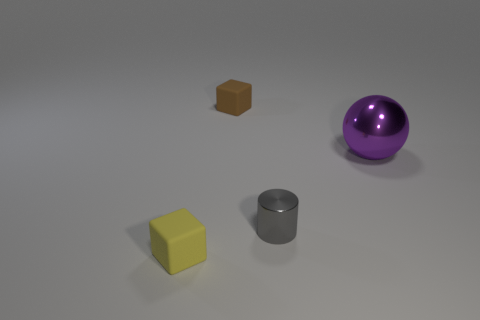Is there a gray metallic cylinder of the same size as the brown object?
Your answer should be very brief. Yes. Are there fewer purple balls behind the big metal ball than things?
Your answer should be very brief. Yes. What is the object behind the large purple thing in front of the rubber block behind the large purple metal object made of?
Ensure brevity in your answer.  Rubber. Is the number of spheres that are to the left of the metal cylinder greater than the number of brown matte things that are on the right side of the metal sphere?
Provide a short and direct response. No. How many shiny objects are small yellow things or small gray things?
Give a very brief answer. 1. There is a block behind the tiny gray metallic cylinder; what is its material?
Ensure brevity in your answer.  Rubber. How many things are small cylinders or things left of the gray thing?
Your answer should be compact. 3. What shape is the metallic thing that is the same size as the yellow cube?
Provide a succinct answer. Cylinder. How many big shiny spheres have the same color as the metal cylinder?
Offer a terse response. 0. Is the block that is on the right side of the yellow matte cube made of the same material as the yellow object?
Give a very brief answer. Yes. 